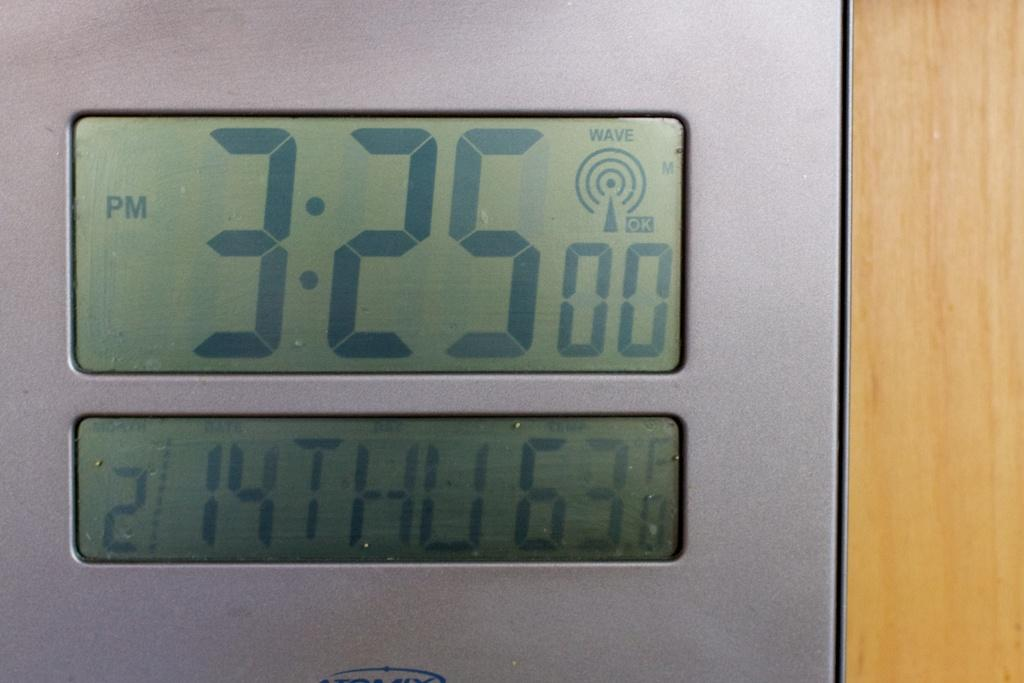<image>
Present a compact description of the photo's key features. A display is showing the day is Thursday and time is 3:25 pm 